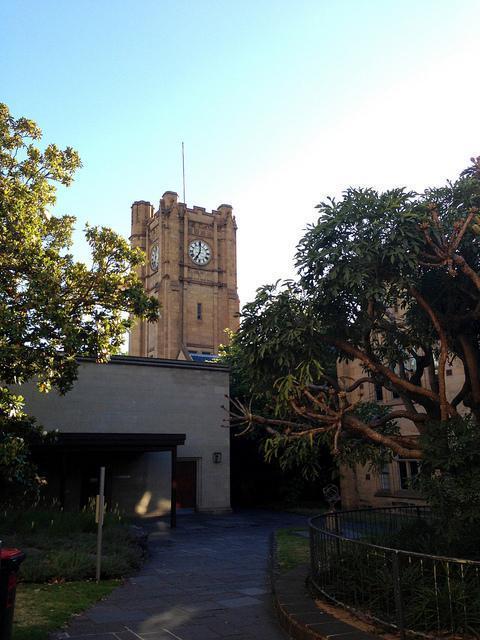How many plant pots are in the lower right quadrant of the photo?
Give a very brief answer. 0. How many round objects in the picture?
Give a very brief answer. 1. 